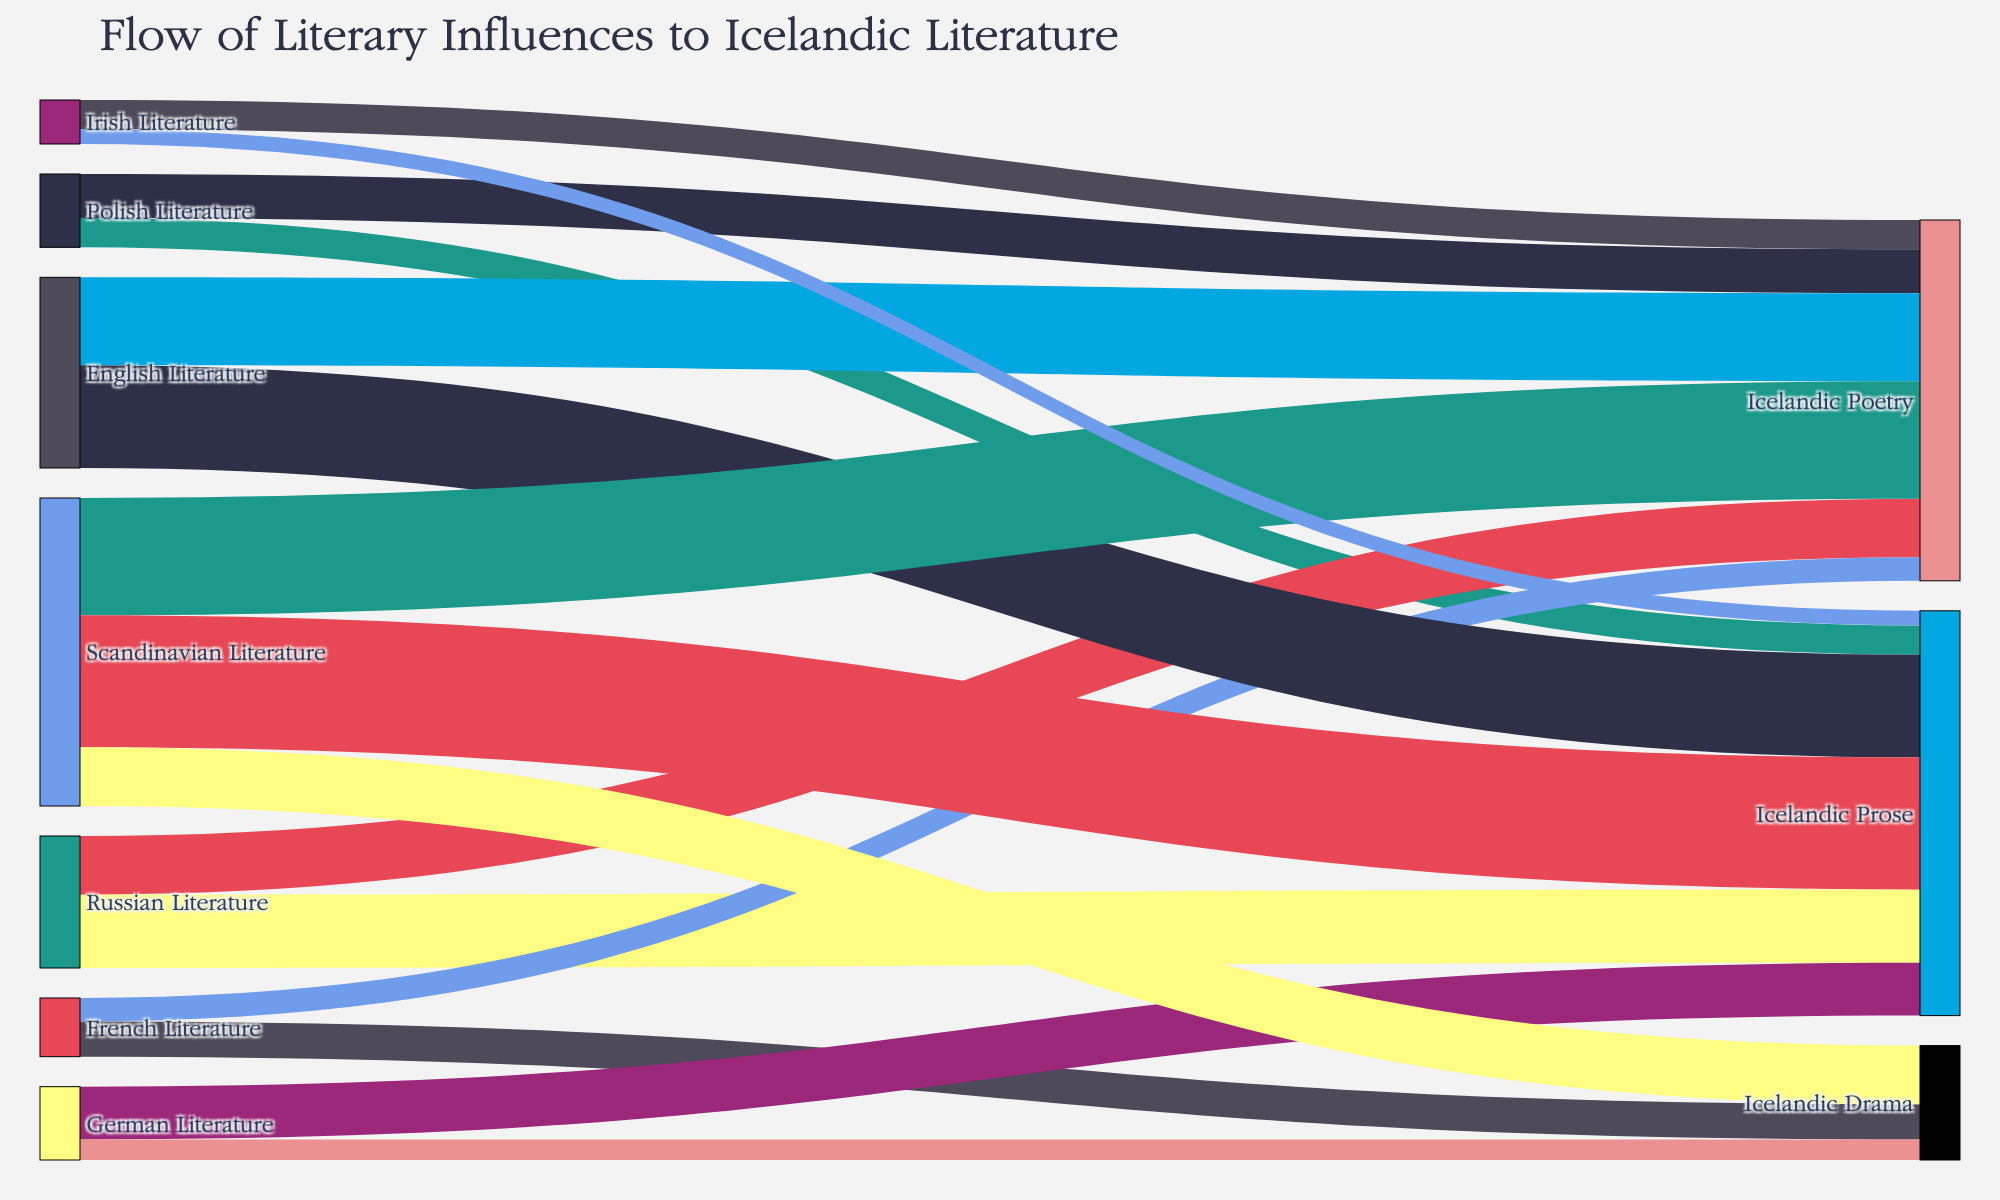What's the most influential source of literary influence on Icelandic Poetry? To determine this, look for the source with the highest flow value leading to Icelandic Poetry. According to the diagram, Scandinavian Literature has a flow value of 40 to Icelandic Poetry.
Answer: Scandinavian Literature How many different genres of Icelandic literature are influenced by French Literature? To answer this, note the different targets connected to French Literature. According to the diagram, French Literature influences Icelandic Drama and Icelandic Poetry.
Answer: Two genres (Drama and Poetry) What is the combined literary influence of Polish and Russian Literature on Icelandic Prose? Add the flow values from Polish and Russian Literature to Icelandic Prose. The respective values are 10 and 25. Adding them together gives 35.
Answer: 35 Which genre of Icelandic literature has received the least influence from Irish Literature? To find this, compare the flow values from Irish Literature to the different genres. For Icelandic Poetry, the value is 10, and for Icelandic Prose, it is 5. Hence, Icelandic Prose receives the least influence.
Answer: Icelandic Prose Compare the influence of English Literature on Icelandic Poetry to German Literature on Icelandic Prose. Which is greater? Look at the flow values for each comparison. English Literature to Icelandic Poetry is 30, and German Literature to Icelandic Prose is 18. Hence, the influence of English Literature on Icelandic Poetry is greater.
Answer: English Literature on Icelandic Poetry How does the total influence on Icelandic Drama compare to the influence on Icelandic Prose? Sum the values going to Icelandic Drama and those going to Icelandic Prose. Icelandic Drama: French (12) + German (7) + Scandinavian (20) = 39. Icelandic Prose: Polish (10) + Russian (25) + German (18) + English (35) + Scandinavian (45) + Irish (5) = 138. Icelandic Prose has a much higher total influence.
Answer: Icelandic Prose has a higher influence What is the total influence from Scandinavian Literature across all Icelandic genres? Sum the flow values from Scandinavian Literature to each target. Icelandic Poetry (40) + Icelandic Prose (45) + Icelandic Drama (20) = 105.
Answer: 105 Which European literature influences the widest range of Icelandic genres? Count the different connections each European Literature source has with different Icelandic genres. Scandinavian Literature connects with Poetry, Prose, and Drama (3 genres) which is the widest range among all.
Answer: Scandinavian Literature Among the sources, which literature has the highest influence on Icelandic Prose? Identify the source connected to Icelandic Prose with the highest value. Scandinavian Literature has the highest value of 45 for Icelandic Prose.
Answer: Scandinavian Literature What's the total influence of all European literary sources on Icelandic Poetry? Sum the values from all sources leading to Icelandic Poetry: Polish (15) + Russian (20) + French (8) + English (30) + Scandinavian (40) + Irish (10) = 123.
Answer: 123 